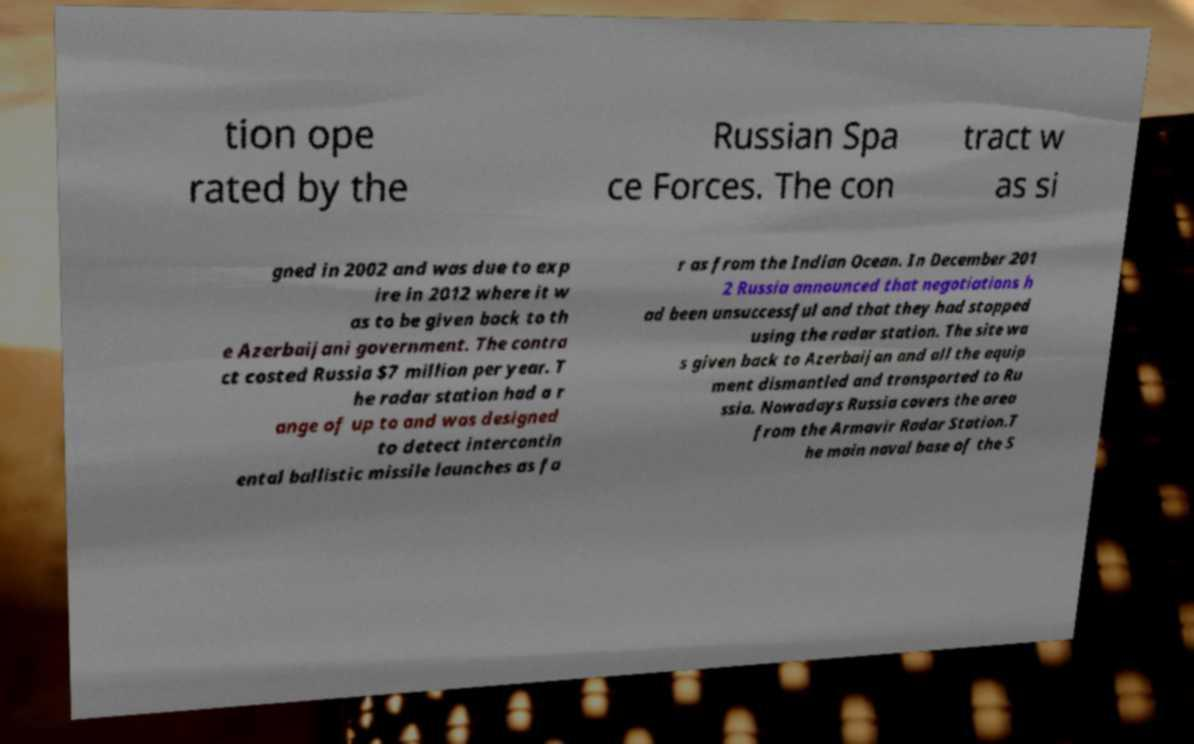Could you assist in decoding the text presented in this image and type it out clearly? tion ope rated by the Russian Spa ce Forces. The con tract w as si gned in 2002 and was due to exp ire in 2012 where it w as to be given back to th e Azerbaijani government. The contra ct costed Russia $7 million per year. T he radar station had a r ange of up to and was designed to detect intercontin ental ballistic missile launches as fa r as from the Indian Ocean. In December 201 2 Russia announced that negotiations h ad been unsuccessful and that they had stopped using the radar station. The site wa s given back to Azerbaijan and all the equip ment dismantled and transported to Ru ssia. Nowadays Russia covers the area from the Armavir Radar Station.T he main naval base of the S 